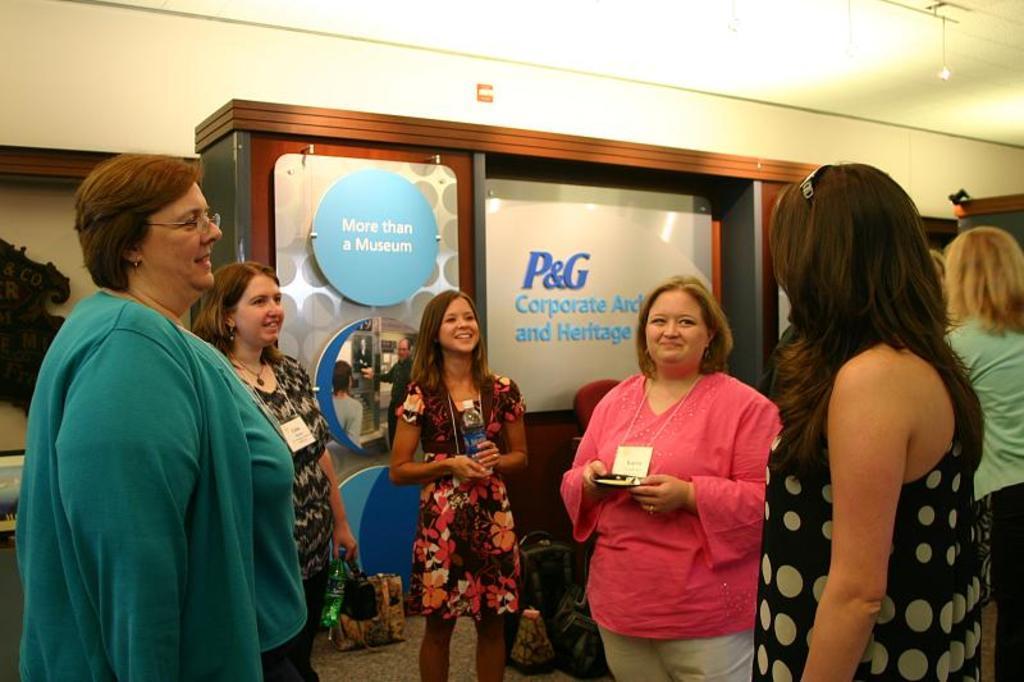Describe this image in one or two sentences. In this picture we can see there is a group of people standing on the floor. Behind the people, there are boards, wall and some objects. 